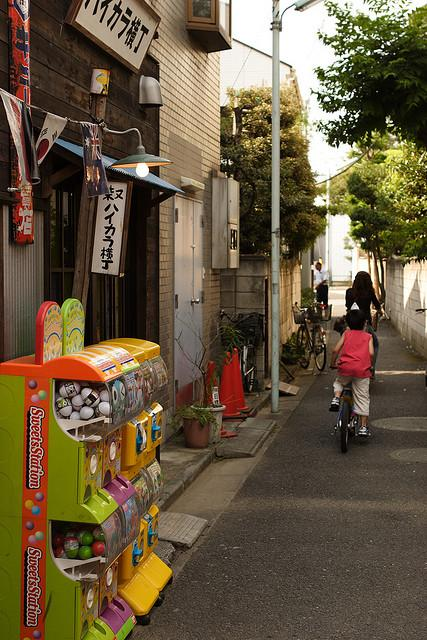What are the colorful machines called? vending machines 